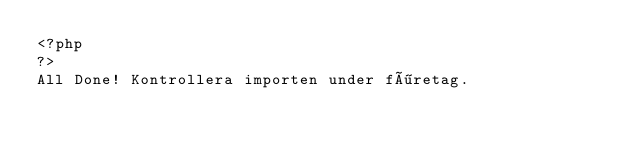Convert code to text. <code><loc_0><loc_0><loc_500><loc_500><_PHP_><?php
?>
All Done! Kontrollera importen under företag.</code> 